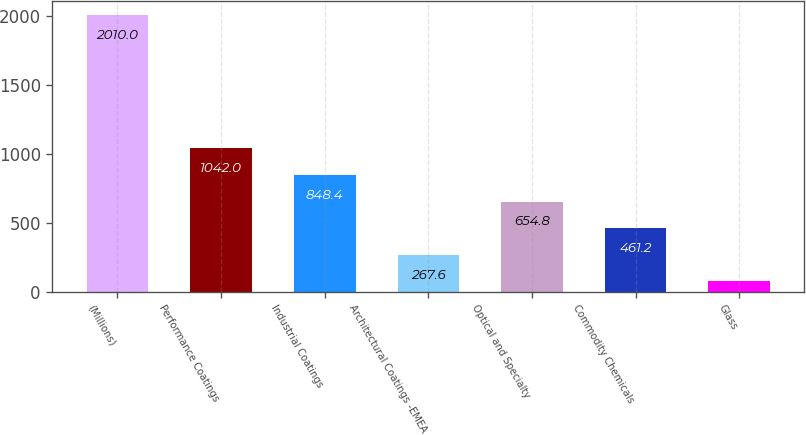<chart> <loc_0><loc_0><loc_500><loc_500><bar_chart><fcel>(Millions)<fcel>Performance Coatings<fcel>Industrial Coatings<fcel>Architectural Coatings -EMEA<fcel>Optical and Specialty<fcel>Commodity Chemicals<fcel>Glass<nl><fcel>2010<fcel>1042<fcel>848.4<fcel>267.6<fcel>654.8<fcel>461.2<fcel>74<nl></chart> 